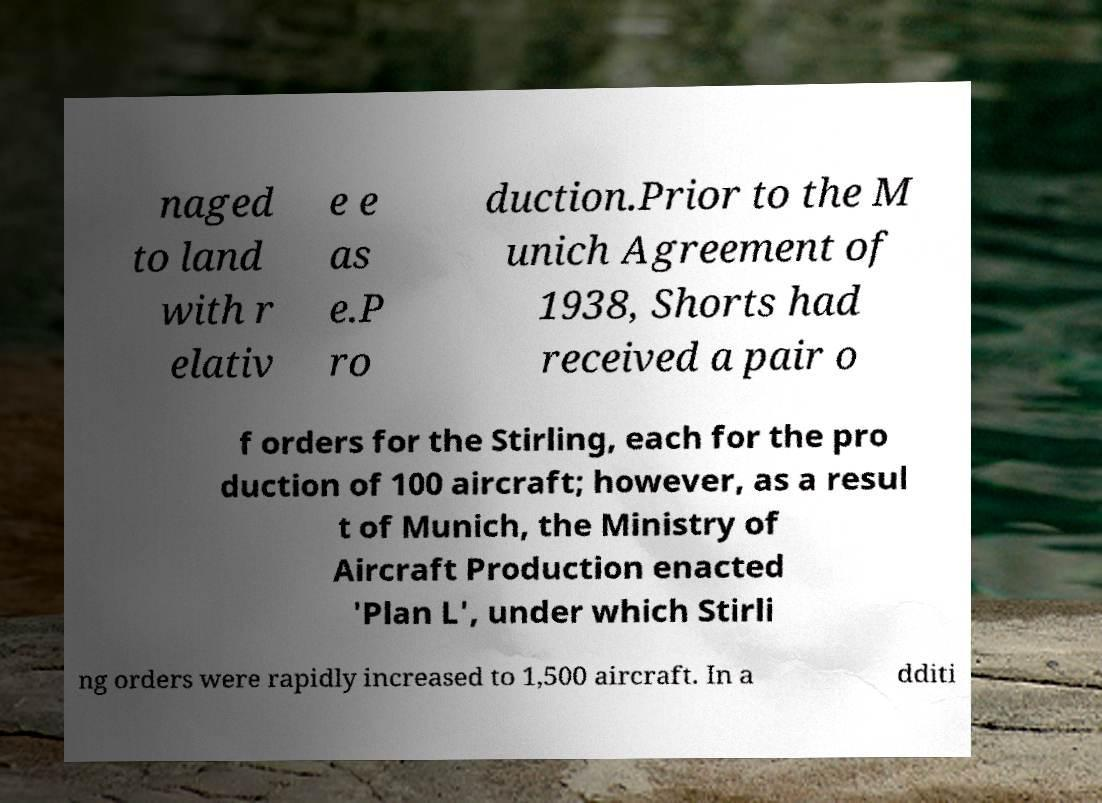Could you extract and type out the text from this image? naged to land with r elativ e e as e.P ro duction.Prior to the M unich Agreement of 1938, Shorts had received a pair o f orders for the Stirling, each for the pro duction of 100 aircraft; however, as a resul t of Munich, the Ministry of Aircraft Production enacted 'Plan L', under which Stirli ng orders were rapidly increased to 1,500 aircraft. In a dditi 